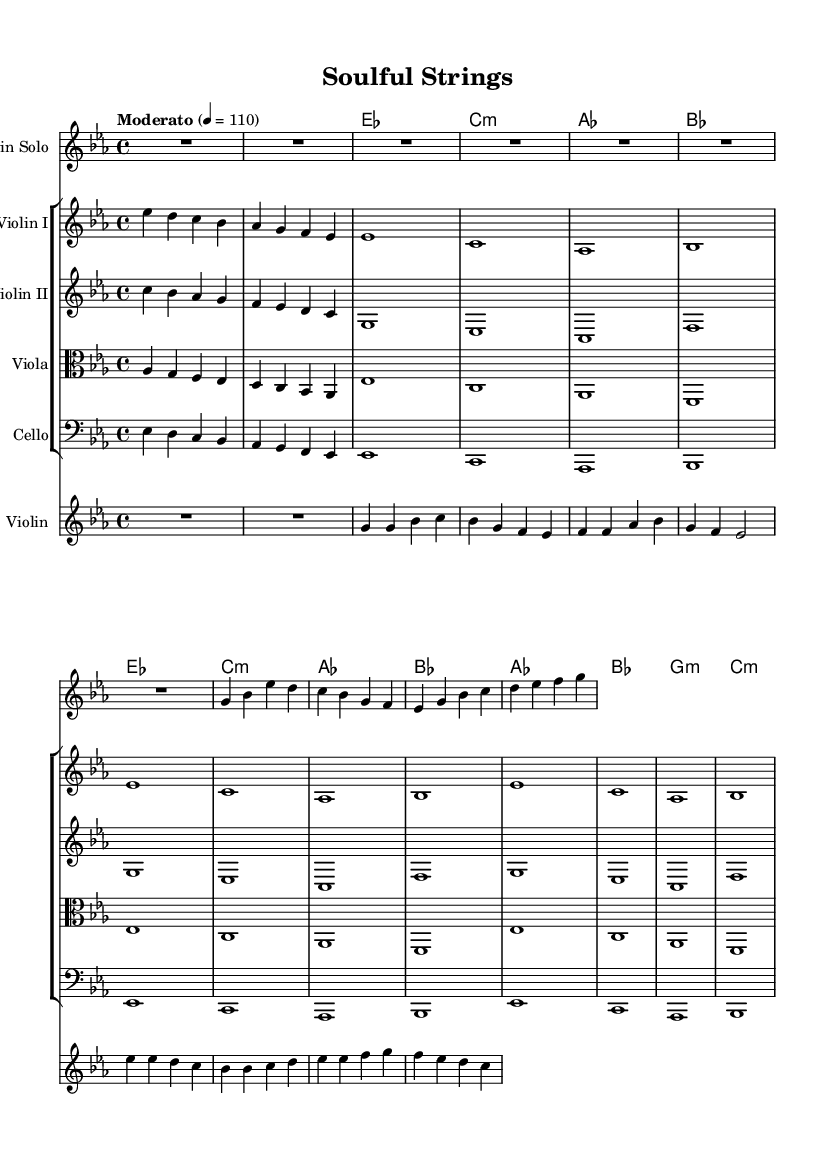What is the key signature of this music? The key signature indicated in the sheet music is E flat major, which has three flats: B flat, E flat, and A flat. This can be determined by looking at the key signature at the beginning of the score.
Answer: E flat major What is the time signature of this music? The time signature shown at the start of the music is 4/4, which means there are four beats in each measure and the quarter note gets one beat. This can be identified by the numbers displayed at the beginning right after the key signature.
Answer: 4/4 What is the tempo marking for this piece? The tempo marking states "Moderato" with a metronome marking of 110 beats per minute, indicating a moderately paced section. This appears at the beginning of the score.
Answer: Moderato How many measures are in the violin solo section? The violin solo section contains a total of 7 measures, which can be counted from the beginning of the violin solo line up to the end of the first section before the rest of the instruments begin.
Answer: 7 What instruments are included in this arrangement? The arrangement includes a Violin Solo, Violin I, Violin II, Viola, Cello, and an additional Violin part. This can be verified by looking at the staff labels in the score.
Answer: Violin Solo, Violin I, Violin II, Viola, Cello, Violin What chords are used in this piece? The chords listed include E flat major, C minor, A flat major, B flat major, G minor, and C minor, as seen in the chord names section of the score. Each chord corresponds to the harmonic structure for the accompaniment.
Answer: E flat major, C minor, A flat major, B flat major, G minor, C minor Which part plays the melody in this arrangement? The melody is primarily played by the Violin Solo, as indicated by its prominence and the lack of accompaniment during its line at the beginning of the score.
Answer: Violin Solo 